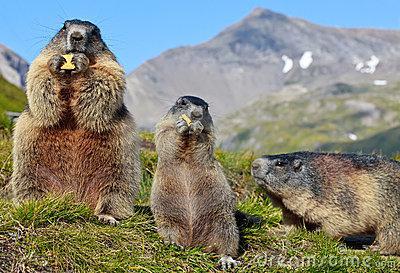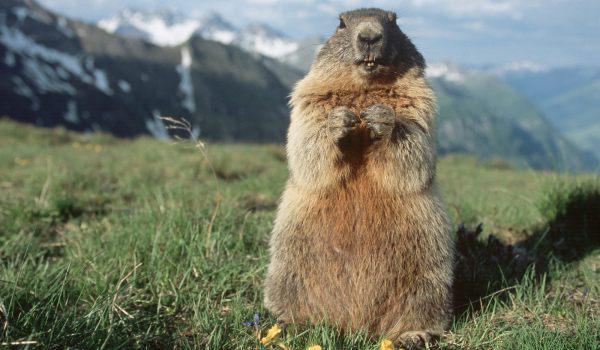The first image is the image on the left, the second image is the image on the right. For the images shown, is this caption "There is at least one animal standing on its hind legs holding something in its front paws." true? Answer yes or no. Yes. The first image is the image on the left, the second image is the image on the right. Evaluate the accuracy of this statement regarding the images: "An image contains at least twice as many marmots as the other image.". Is it true? Answer yes or no. Yes. 